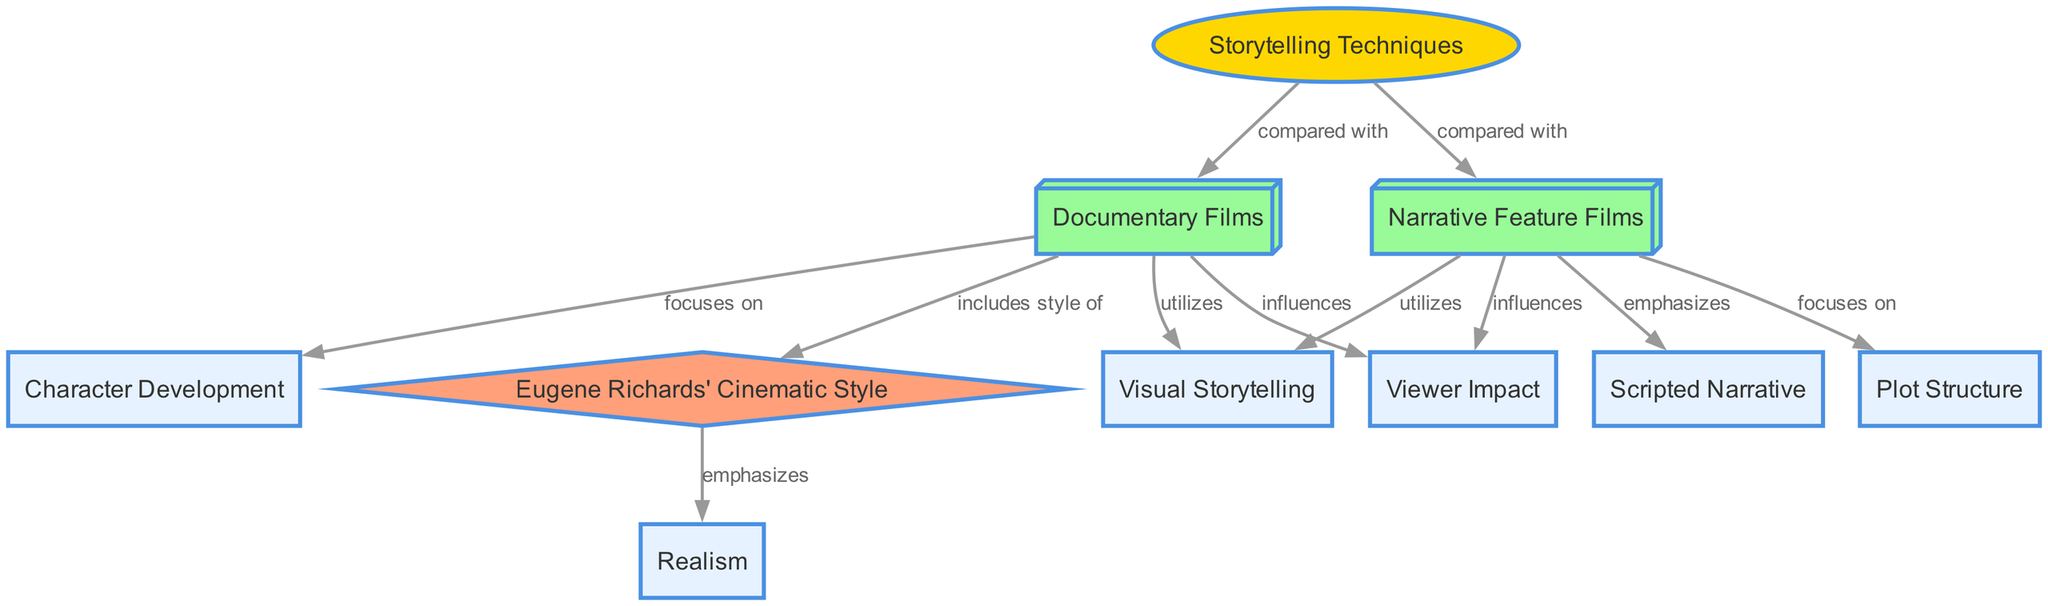What are the two types of films compared in this diagram? The nodes labeled "Documentary Films" and "Narrative Feature Films" represent the two types of films being compared in the diagram.
Answer: Documentary Films, Narrative Feature Films How many nodes are present in this diagram? By counting the nodes listed in the provided data, there are a total of 10 nodes included in the diagram.
Answer: 10 Which node emphasizes realism? The edge connecting "Eugene Richards' Cinematic Style" to "Realism" indicates that Eugene Richards' style emphasizes realism.
Answer: Realism What storytelling technique do both documentary and narrative feature films utilize? The edges showing both documentary films and narrative feature films leading to "Visual Storytelling" indicate that both types utilize this technique.
Answer: Visual Storytelling What does "Documentary Films" focus on? The edge from "Documentary Films" to "Character Development" reveals that this type of film focuses on character development.
Answer: Character Development Which node shows the influence of both types of films on viewers? The edges from "Documentary Films" and "Narrative Feature Films" to "Viewer Impact" show that both types influence viewer impact.
Answer: Viewer Impact What type of narrative technique is emphasized by Narrative Feature Films? The edge directly connecting "Narrative Feature Films" to "Scripted Narrative" indicates that this type emphasizes scripted narrative.
Answer: Scripted Narrative What connects Eugene Richards' style with documentary films? The edge labeled "includes style of" connects "Documentary Films" to "Eugene Richards' Cinematic Style," illustrating that his style is part of documentary filmmaking.
Answer: includes style of Which storytelling technique is focused on by Narrative Feature Films? The edge connecting "Narrative Feature Films" to "Plot Structure" indicates that this type focuses on plot structure.
Answer: Plot Structure 